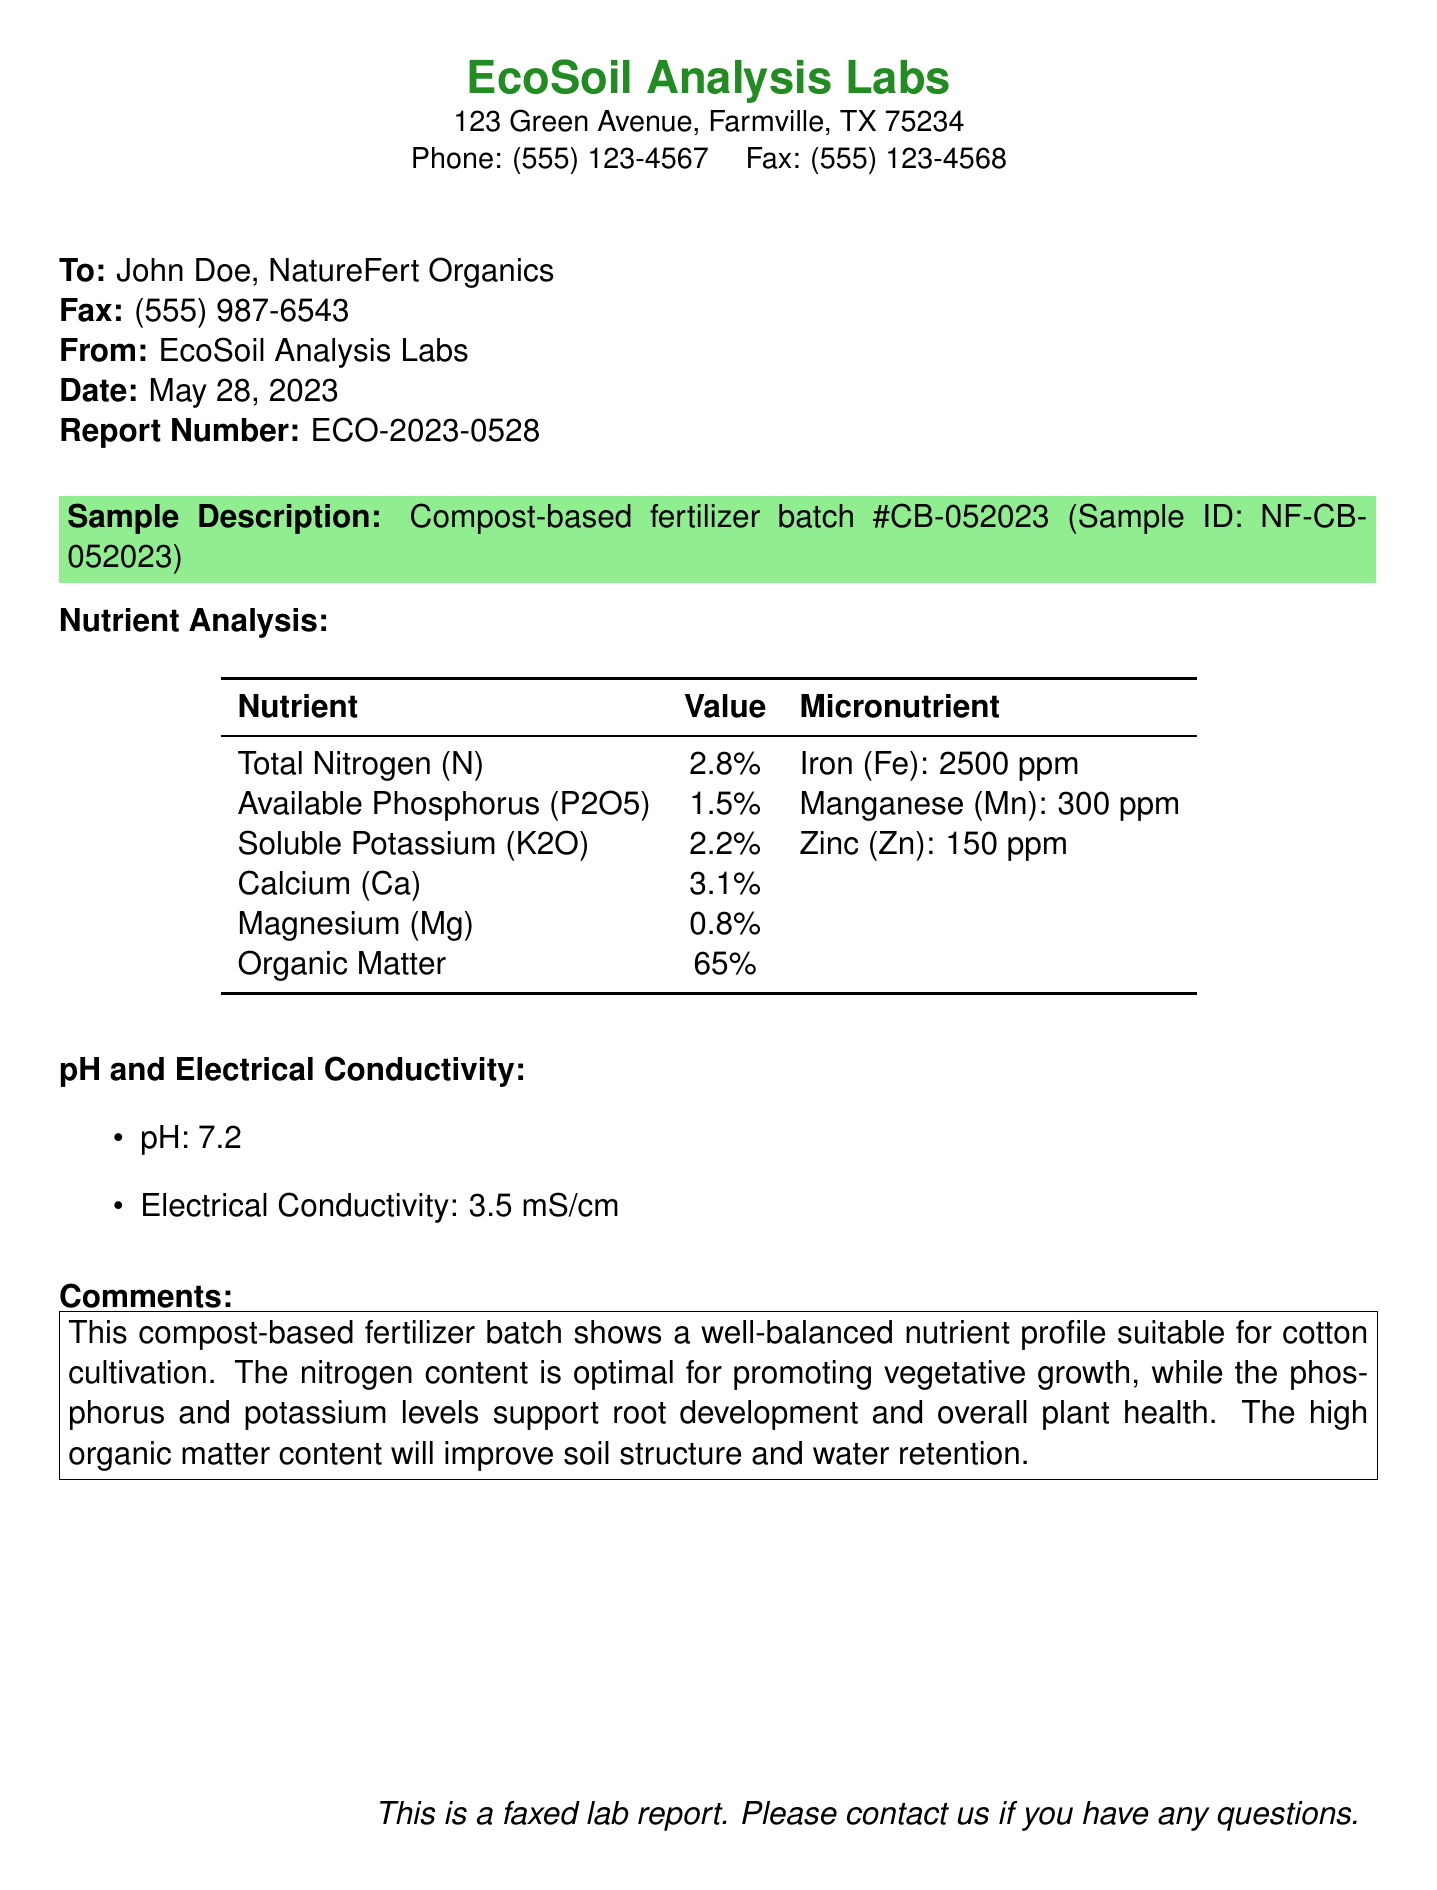what is the total nitrogen percentage in the fertilizer? The total nitrogen percentage is stated clearly in the nutrient analysis section of the document.
Answer: 2.8% who is the recipient of the fax? The recipient's name is specified at the beginning of the fax.
Answer: John Doe what is the pH level of the compost-based fertilizer? The pH level is mentioned in the section detailing pH and electrical conductivity.
Answer: 7.2 how much organic matter does the fertilizer contain? The organic matter content is listed in the nutrient analysis table.
Answer: 65% what micronutrient has the highest concentration? The micronutrient concentrations are listed in the nutrient analysis section; the highest is noted clearly.
Answer: Iron (Fe) is the phosphorus level suitable for cotton cultivation? The comments section summarizes the suitability of nutrient levels for cotton cultivation.
Answer: Yes how many parts per million of zinc are present in the fertilizer? The amount of zinc is indicated in the micronutrient section of the nutrient analysis.
Answer: 150 ppm when was the lab report faxed? The date of the fax is listed prominently in the header of the document.
Answer: May 28, 2023 what is the report number? The report number is clearly stated in the header information of the fax.
Answer: ECO-2023-0528 